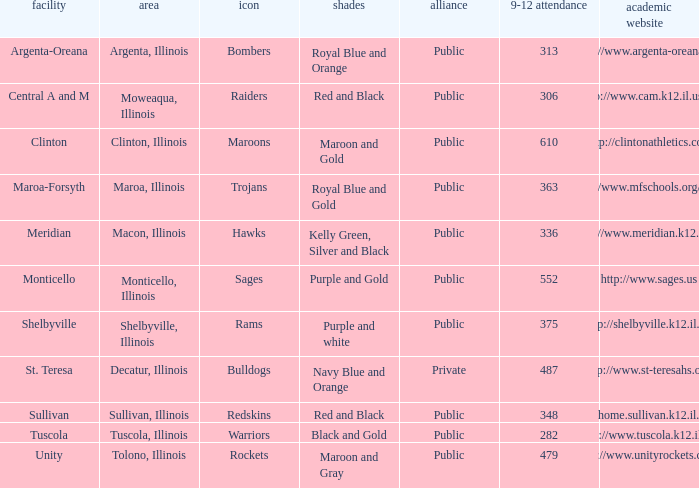What's the name of the city or town of the school that operates the http://www.mfschools.org/high/ website? Maroa-Forsyth. 